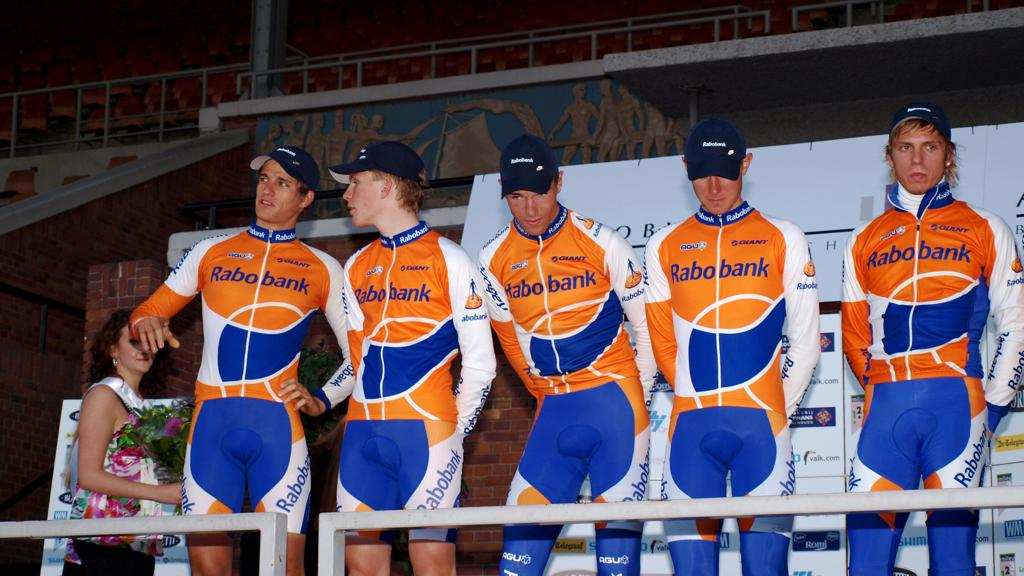<image>
Summarize the visual content of the image. Men in Rabobank sponsored outfits are standing in a line. 